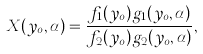<formula> <loc_0><loc_0><loc_500><loc_500>X ( y _ { o } , \alpha ) = \frac { f _ { 1 } ( y _ { o } ) g _ { 1 } ( y _ { o } , \alpha ) } { f _ { 2 } ( y _ { o } ) g _ { 2 } ( y _ { o } , \alpha ) } ,</formula> 